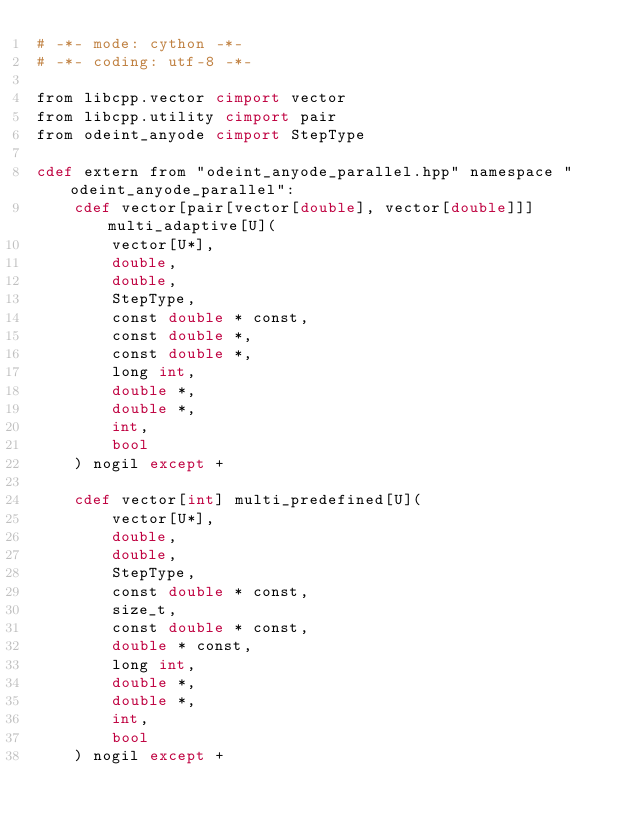Convert code to text. <code><loc_0><loc_0><loc_500><loc_500><_Cython_># -*- mode: cython -*-
# -*- coding: utf-8 -*-

from libcpp.vector cimport vector
from libcpp.utility cimport pair
from odeint_anyode cimport StepType

cdef extern from "odeint_anyode_parallel.hpp" namespace "odeint_anyode_parallel":
    cdef vector[pair[vector[double], vector[double]]] multi_adaptive[U](
        vector[U*],
        double,
        double,
        StepType,
        const double * const,
        const double *,
        const double *,
        long int,
        double *,
        double *,
        int,
        bool
    ) nogil except +

    cdef vector[int] multi_predefined[U](
        vector[U*],
        double,
        double,
        StepType,
        const double * const,
        size_t,
        const double * const,
        double * const,
        long int,
        double *,
        double *,
        int,
        bool
    ) nogil except +
</code> 